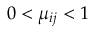<formula> <loc_0><loc_0><loc_500><loc_500>0 < \mu _ { i j } < 1</formula> 